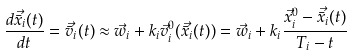Convert formula to latex. <formula><loc_0><loc_0><loc_500><loc_500>\frac { d \vec { \bar { x } } _ { i } ( t ) } { d t } = \vec { \bar { v } } _ { i } ( t ) \approx \vec { w } _ { i } + k _ { i } \vec { v } _ { i } ^ { 0 } ( \vec { \bar { x } } _ { i } ( t ) ) = \vec { w } _ { i } + k _ { i } \frac { \vec { x } _ { i } ^ { 0 } - \vec { \bar { x } } _ { i } ( t ) } { T _ { i } - t }</formula> 